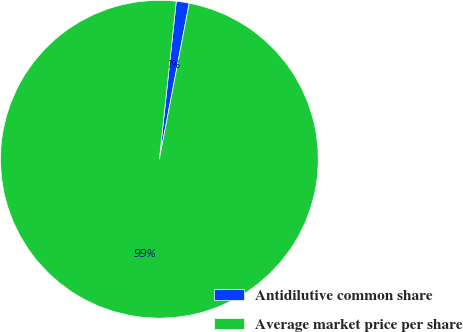Convert chart. <chart><loc_0><loc_0><loc_500><loc_500><pie_chart><fcel>Antidilutive common share<fcel>Average market price per share<nl><fcel>1.31%<fcel>98.69%<nl></chart> 